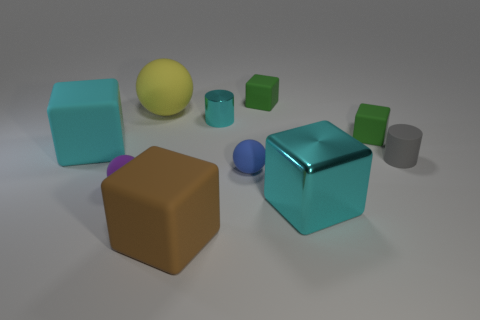Which objects in the image are closest to each other? In the image, the cyan metallic cube and the small grey cylinder appear to be the closest to each other. Their proximity, as depicted, is closer relative to the arrangement of other objects on the surface. 